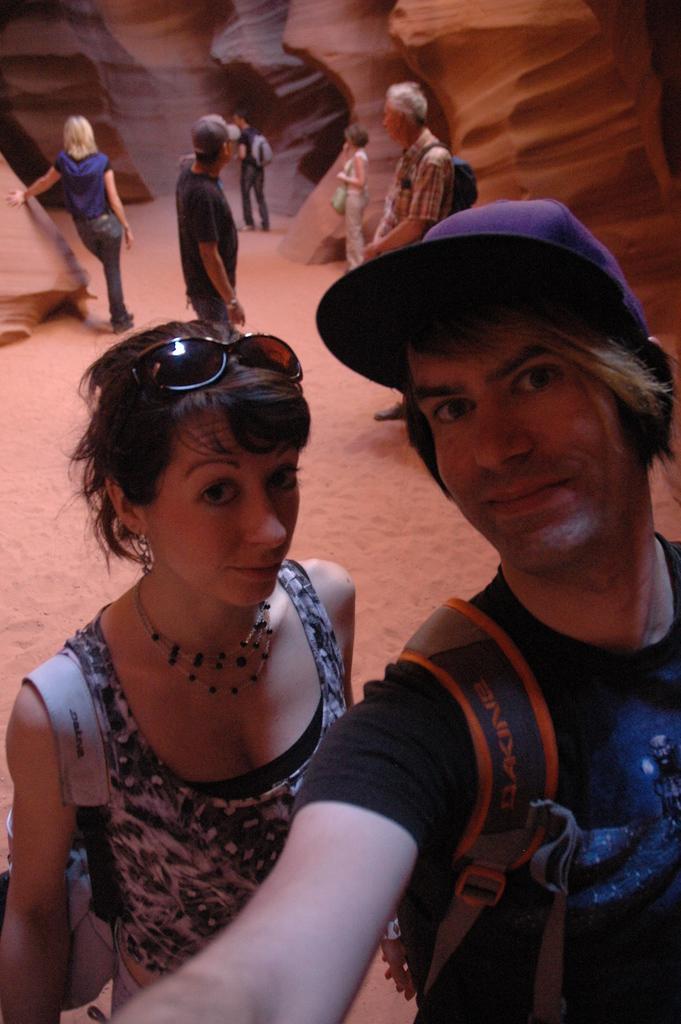How would you summarize this image in a sentence or two? In the image there are two people in the foreground, it looks like they are taking a selfie and behind them there are few other people. 